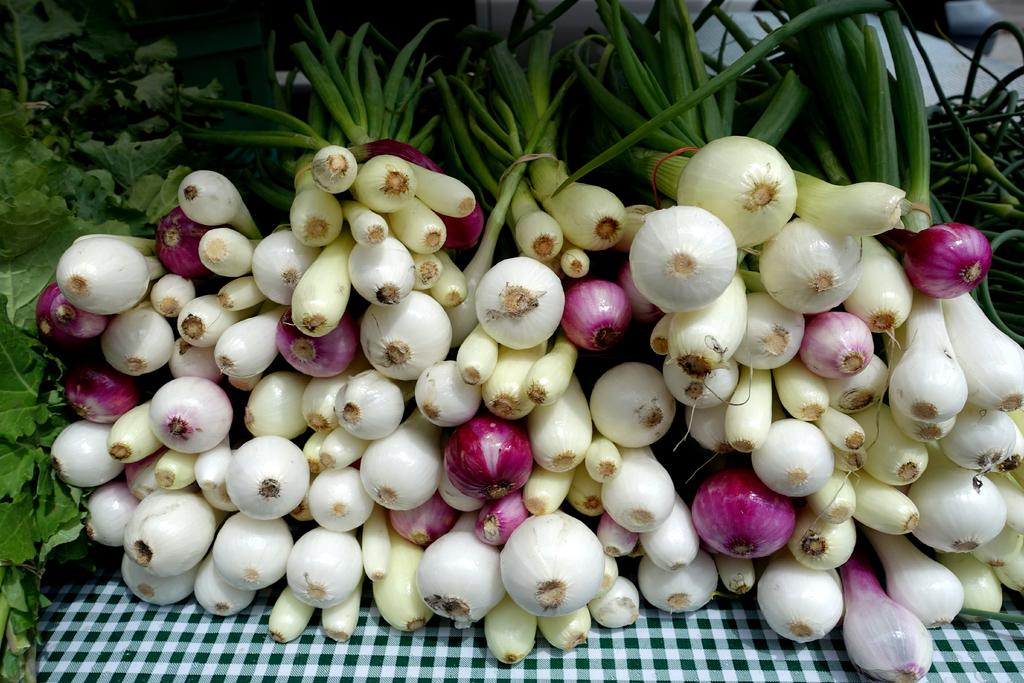What type of vegetable can be seen in the image? There are onions in the image. What other plant material is present in the image? There are leaves in the image. On what surface are the onions and leaves placed? The onions and leaves are placed on a cloth. What type of salt is sprinkled on top of the onions in the image? There is no salt present in the image; it only features onions and leaves placed on a cloth. 